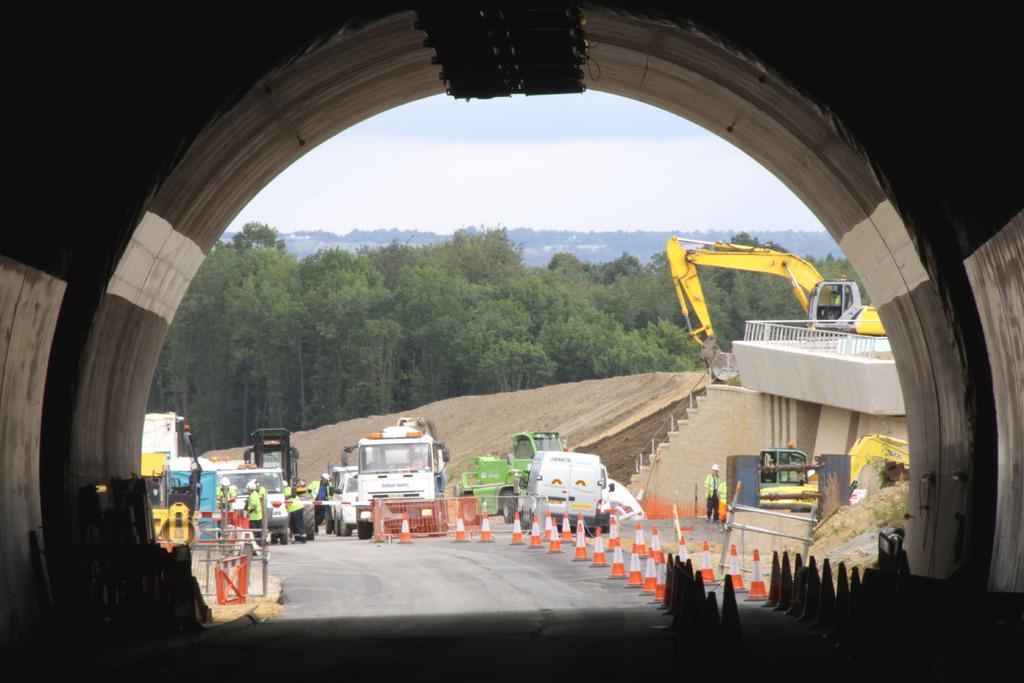How would you summarize this image in a sentence or two? In the picture we can see a road and far away from it, we can see some vehicles like trucks and cars and behind it, we can see a machinery equipment which is yellow in color and behind it we can see trees, hills and sky. 